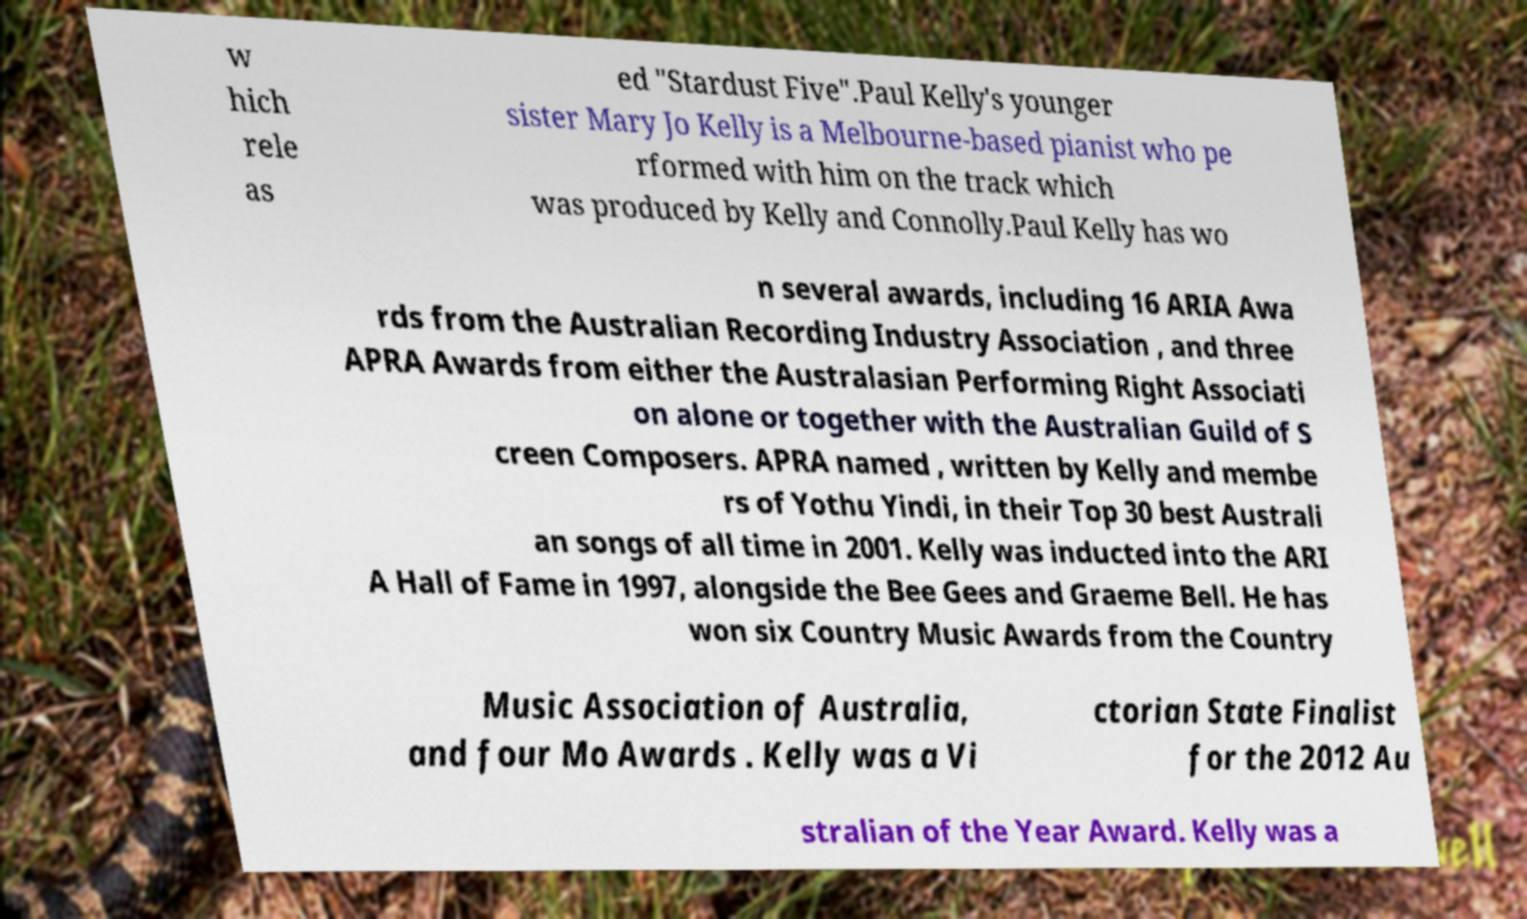Please identify and transcribe the text found in this image. w hich rele as ed "Stardust Five".Paul Kelly's younger sister Mary Jo Kelly is a Melbourne-based pianist who pe rformed with him on the track which was produced by Kelly and Connolly.Paul Kelly has wo n several awards, including 16 ARIA Awa rds from the Australian Recording Industry Association , and three APRA Awards from either the Australasian Performing Right Associati on alone or together with the Australian Guild of S creen Composers. APRA named , written by Kelly and membe rs of Yothu Yindi, in their Top 30 best Australi an songs of all time in 2001. Kelly was inducted into the ARI A Hall of Fame in 1997, alongside the Bee Gees and Graeme Bell. He has won six Country Music Awards from the Country Music Association of Australia, and four Mo Awards . Kelly was a Vi ctorian State Finalist for the 2012 Au stralian of the Year Award. Kelly was a 